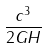<formula> <loc_0><loc_0><loc_500><loc_500>\frac { c ^ { 3 } } { 2 G H }</formula> 